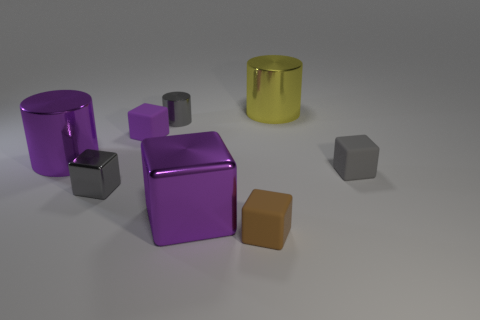Subtract 1 blocks. How many blocks are left? 4 Subtract all red blocks. Subtract all green cylinders. How many blocks are left? 5 Add 1 tiny cylinders. How many objects exist? 9 Subtract all cubes. How many objects are left? 3 Add 6 tiny gray cylinders. How many tiny gray cylinders are left? 7 Add 5 tiny matte things. How many tiny matte things exist? 8 Subtract 0 red spheres. How many objects are left? 8 Subtract all small cylinders. Subtract all tiny cylinders. How many objects are left? 6 